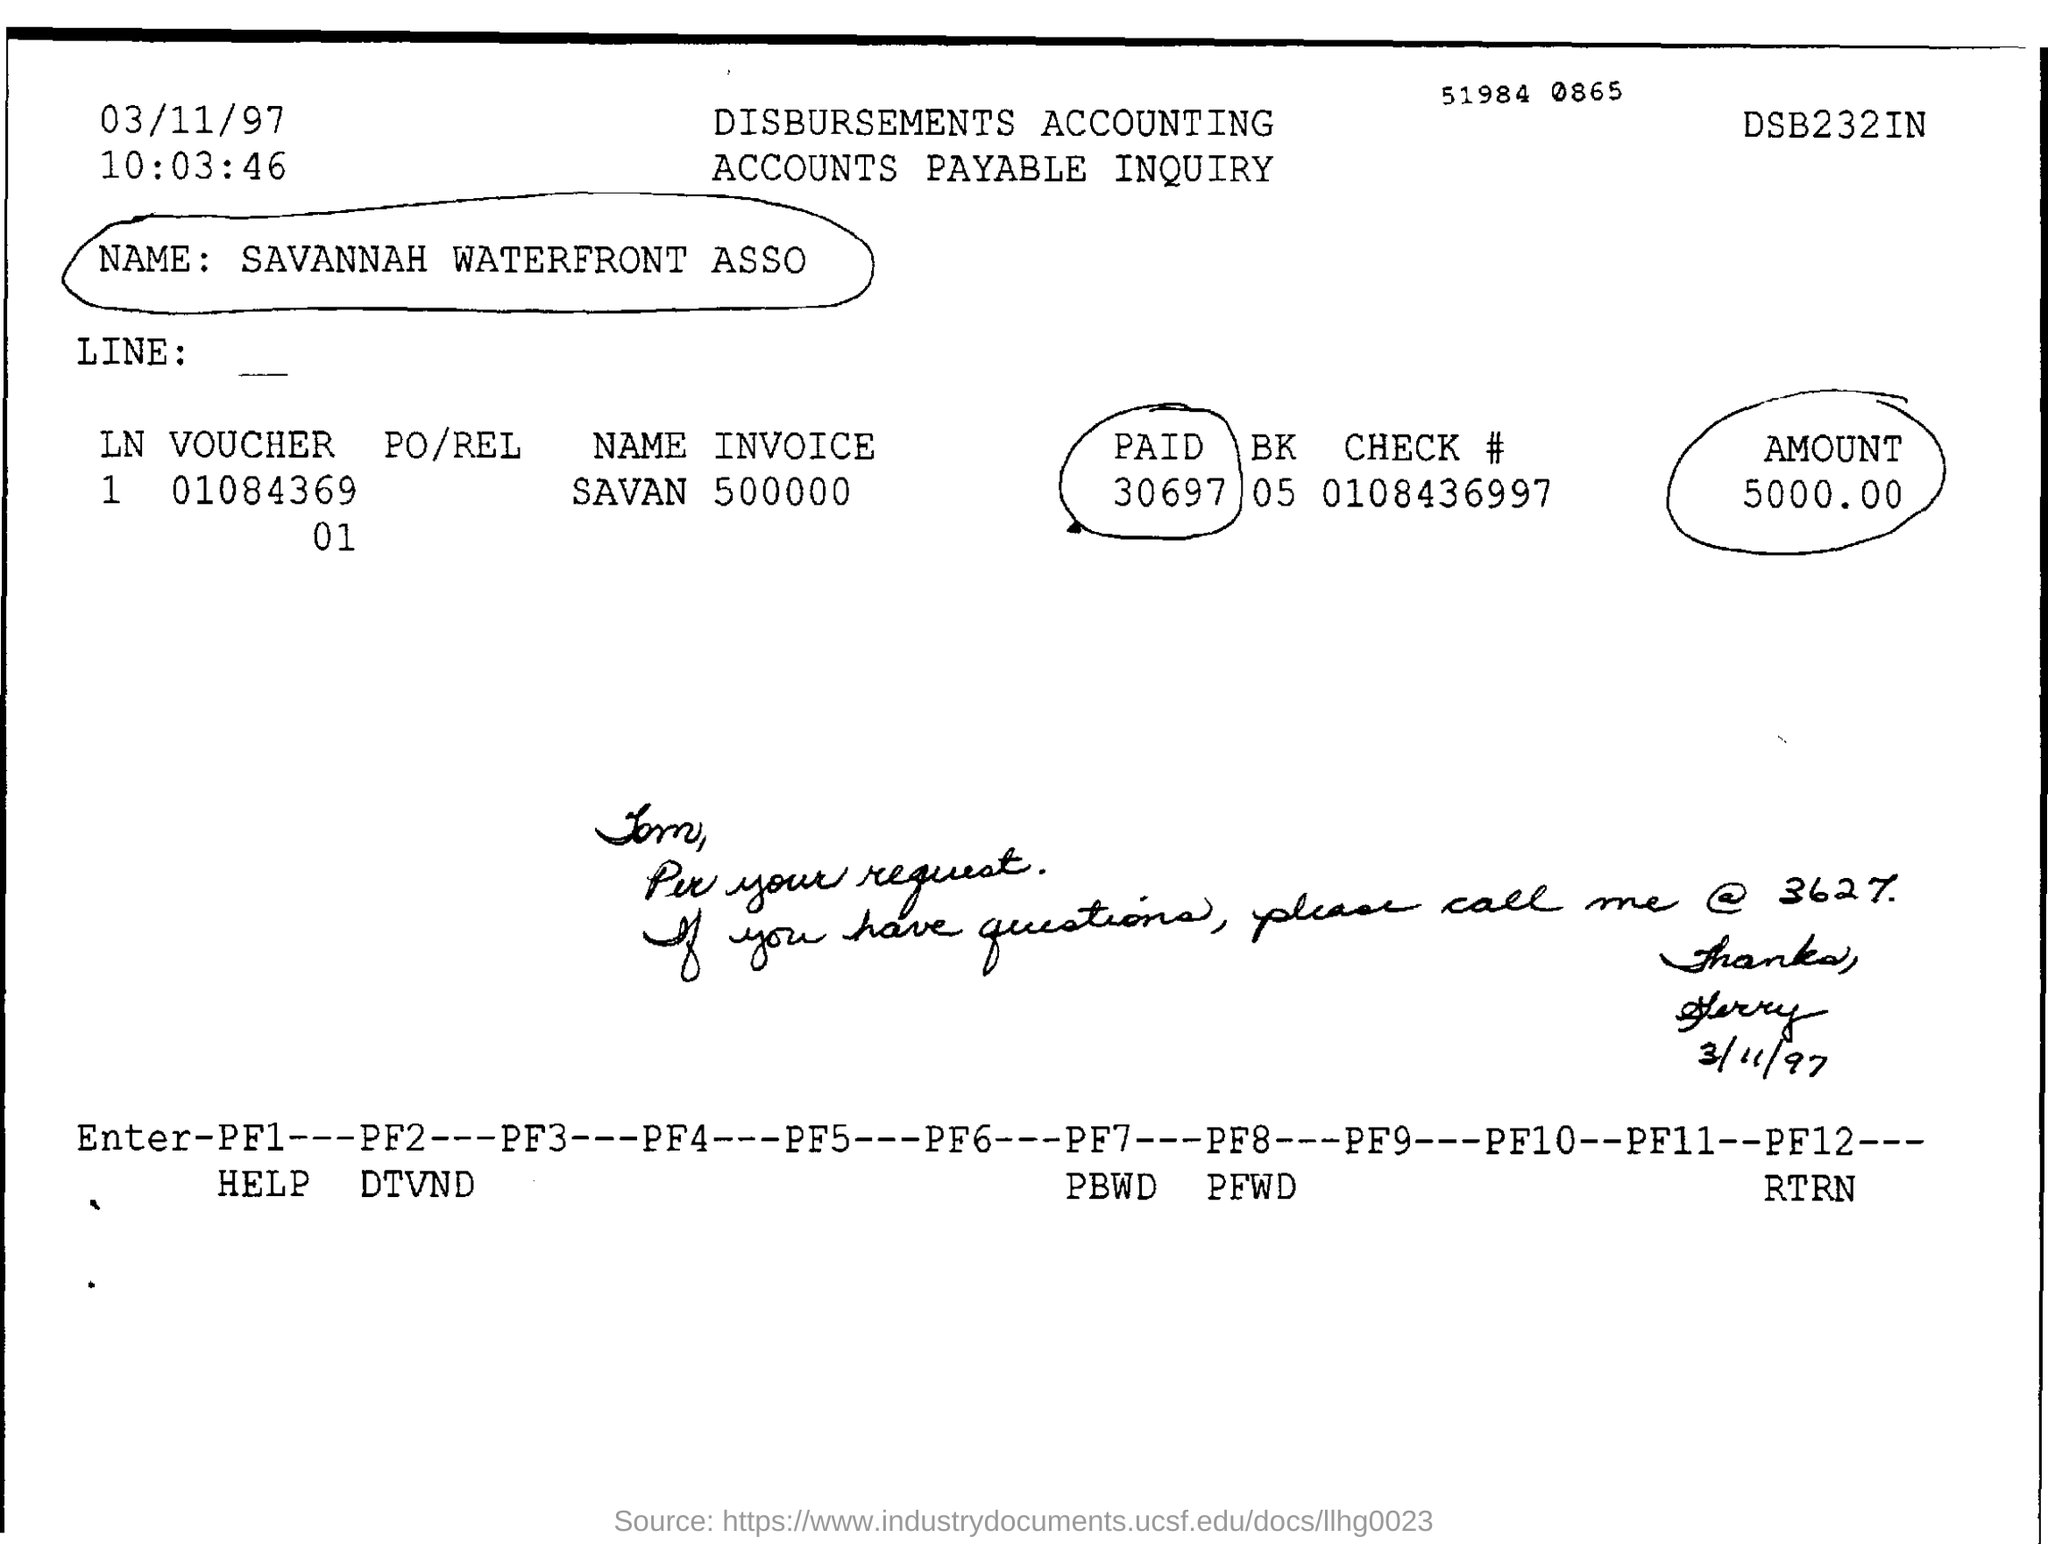Outline some significant characteristics in this image. The document title is 'Disburse The document is dated March 11, 1997. The check number is 0108436997. Is the amount specified 5000.00? I have determined that the name given is 'SAVANNAH WATERFRONT ASSOCIATION' 